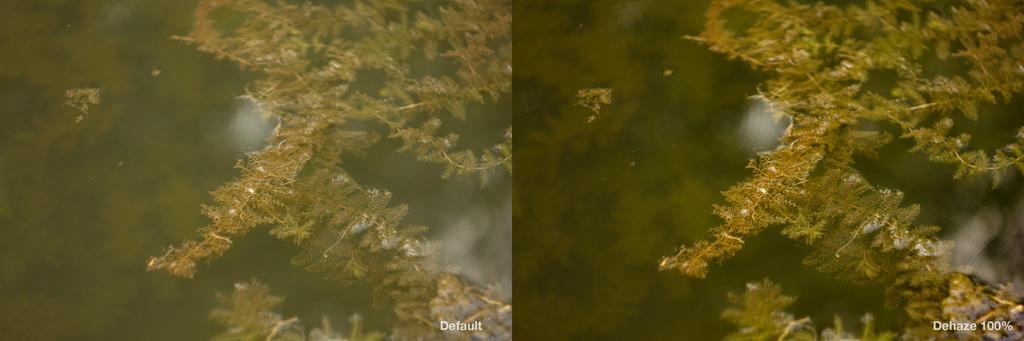Could you give a brief overview of what you see in this image? In this image, we can see water, there are some wildflowers in the water. 